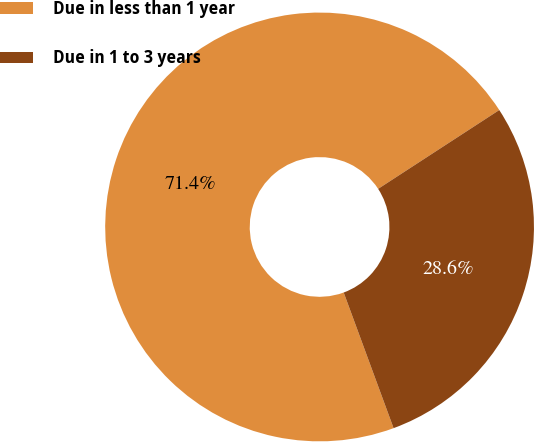Convert chart. <chart><loc_0><loc_0><loc_500><loc_500><pie_chart><fcel>Due in less than 1 year<fcel>Due in 1 to 3 years<nl><fcel>71.43%<fcel>28.57%<nl></chart> 